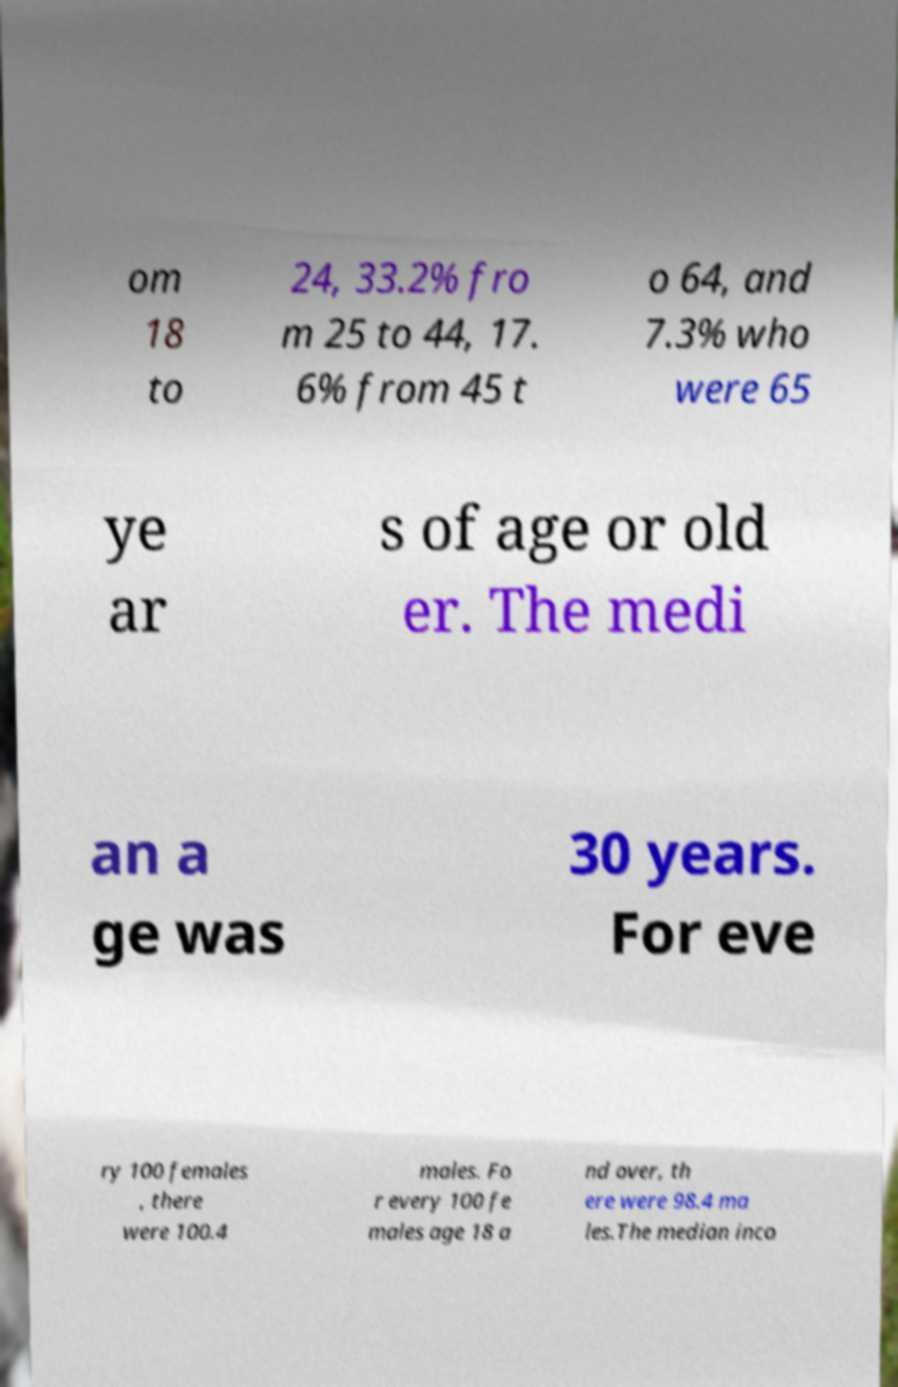For documentation purposes, I need the text within this image transcribed. Could you provide that? om 18 to 24, 33.2% fro m 25 to 44, 17. 6% from 45 t o 64, and 7.3% who were 65 ye ar s of age or old er. The medi an a ge was 30 years. For eve ry 100 females , there were 100.4 males. Fo r every 100 fe males age 18 a nd over, th ere were 98.4 ma les.The median inco 